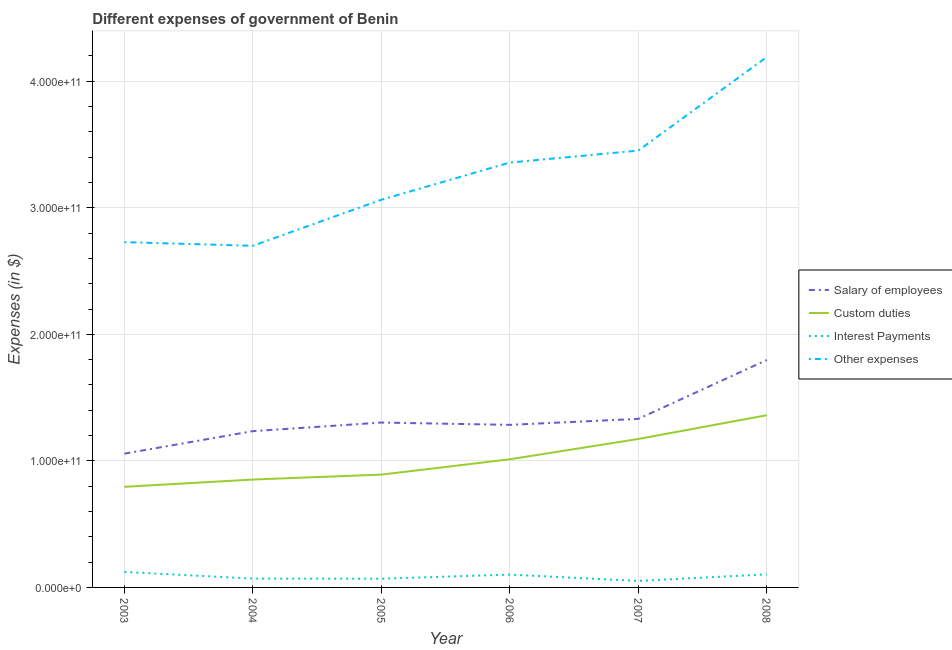How many different coloured lines are there?
Provide a succinct answer. 4. Does the line corresponding to amount spent on custom duties intersect with the line corresponding to amount spent on salary of employees?
Provide a succinct answer. No. Is the number of lines equal to the number of legend labels?
Your answer should be compact. Yes. What is the amount spent on custom duties in 2003?
Make the answer very short. 7.95e+1. Across all years, what is the maximum amount spent on other expenses?
Keep it short and to the point. 4.19e+11. Across all years, what is the minimum amount spent on interest payments?
Provide a succinct answer. 5.13e+09. In which year was the amount spent on custom duties maximum?
Ensure brevity in your answer.  2008. What is the total amount spent on custom duties in the graph?
Your response must be concise. 6.09e+11. What is the difference between the amount spent on interest payments in 2003 and that in 2007?
Ensure brevity in your answer.  7.14e+09. What is the difference between the amount spent on salary of employees in 2005 and the amount spent on custom duties in 2008?
Your answer should be compact. -5.80e+09. What is the average amount spent on salary of employees per year?
Offer a very short reply. 1.33e+11. In the year 2008, what is the difference between the amount spent on salary of employees and amount spent on custom duties?
Make the answer very short. 4.36e+1. In how many years, is the amount spent on interest payments greater than 140000000000 $?
Provide a succinct answer. 0. What is the ratio of the amount spent on other expenses in 2007 to that in 2008?
Keep it short and to the point. 0.82. What is the difference between the highest and the second highest amount spent on other expenses?
Your answer should be compact. 7.39e+1. What is the difference between the highest and the lowest amount spent on custom duties?
Make the answer very short. 5.66e+1. In how many years, is the amount spent on custom duties greater than the average amount spent on custom duties taken over all years?
Offer a very short reply. 2. Is it the case that in every year, the sum of the amount spent on interest payments and amount spent on other expenses is greater than the sum of amount spent on custom duties and amount spent on salary of employees?
Provide a succinct answer. Yes. Is the amount spent on custom duties strictly greater than the amount spent on other expenses over the years?
Make the answer very short. No. Is the amount spent on interest payments strictly less than the amount spent on salary of employees over the years?
Give a very brief answer. Yes. What is the difference between two consecutive major ticks on the Y-axis?
Your answer should be very brief. 1.00e+11. Are the values on the major ticks of Y-axis written in scientific E-notation?
Give a very brief answer. Yes. Does the graph contain any zero values?
Give a very brief answer. No. Does the graph contain grids?
Your response must be concise. Yes. How are the legend labels stacked?
Provide a short and direct response. Vertical. What is the title of the graph?
Offer a terse response. Different expenses of government of Benin. Does "Luxembourg" appear as one of the legend labels in the graph?
Keep it short and to the point. No. What is the label or title of the Y-axis?
Give a very brief answer. Expenses (in $). What is the Expenses (in $) of Salary of employees in 2003?
Keep it short and to the point. 1.06e+11. What is the Expenses (in $) of Custom duties in 2003?
Give a very brief answer. 7.95e+1. What is the Expenses (in $) in Interest Payments in 2003?
Offer a very short reply. 1.23e+1. What is the Expenses (in $) of Other expenses in 2003?
Ensure brevity in your answer.  2.73e+11. What is the Expenses (in $) of Salary of employees in 2004?
Your response must be concise. 1.23e+11. What is the Expenses (in $) in Custom duties in 2004?
Provide a short and direct response. 8.52e+1. What is the Expenses (in $) in Interest Payments in 2004?
Give a very brief answer. 6.97e+09. What is the Expenses (in $) of Other expenses in 2004?
Offer a very short reply. 2.70e+11. What is the Expenses (in $) in Salary of employees in 2005?
Ensure brevity in your answer.  1.30e+11. What is the Expenses (in $) in Custom duties in 2005?
Keep it short and to the point. 8.91e+1. What is the Expenses (in $) in Interest Payments in 2005?
Make the answer very short. 6.89e+09. What is the Expenses (in $) in Other expenses in 2005?
Provide a succinct answer. 3.06e+11. What is the Expenses (in $) in Salary of employees in 2006?
Keep it short and to the point. 1.28e+11. What is the Expenses (in $) of Custom duties in 2006?
Offer a very short reply. 1.01e+11. What is the Expenses (in $) of Interest Payments in 2006?
Your answer should be very brief. 1.01e+1. What is the Expenses (in $) of Other expenses in 2006?
Ensure brevity in your answer.  3.36e+11. What is the Expenses (in $) of Salary of employees in 2007?
Make the answer very short. 1.33e+11. What is the Expenses (in $) in Custom duties in 2007?
Your answer should be compact. 1.17e+11. What is the Expenses (in $) of Interest Payments in 2007?
Make the answer very short. 5.13e+09. What is the Expenses (in $) in Other expenses in 2007?
Provide a succinct answer. 3.45e+11. What is the Expenses (in $) in Salary of employees in 2008?
Ensure brevity in your answer.  1.80e+11. What is the Expenses (in $) in Custom duties in 2008?
Offer a terse response. 1.36e+11. What is the Expenses (in $) of Interest Payments in 2008?
Your answer should be compact. 1.03e+1. What is the Expenses (in $) in Other expenses in 2008?
Ensure brevity in your answer.  4.19e+11. Across all years, what is the maximum Expenses (in $) of Salary of employees?
Give a very brief answer. 1.80e+11. Across all years, what is the maximum Expenses (in $) of Custom duties?
Your answer should be very brief. 1.36e+11. Across all years, what is the maximum Expenses (in $) of Interest Payments?
Make the answer very short. 1.23e+1. Across all years, what is the maximum Expenses (in $) in Other expenses?
Offer a terse response. 4.19e+11. Across all years, what is the minimum Expenses (in $) in Salary of employees?
Ensure brevity in your answer.  1.06e+11. Across all years, what is the minimum Expenses (in $) in Custom duties?
Provide a short and direct response. 7.95e+1. Across all years, what is the minimum Expenses (in $) of Interest Payments?
Give a very brief answer. 5.13e+09. Across all years, what is the minimum Expenses (in $) of Other expenses?
Your answer should be compact. 2.70e+11. What is the total Expenses (in $) in Salary of employees in the graph?
Your response must be concise. 8.01e+11. What is the total Expenses (in $) of Custom duties in the graph?
Your answer should be compact. 6.09e+11. What is the total Expenses (in $) of Interest Payments in the graph?
Keep it short and to the point. 5.17e+1. What is the total Expenses (in $) in Other expenses in the graph?
Your answer should be compact. 1.95e+12. What is the difference between the Expenses (in $) in Salary of employees in 2003 and that in 2004?
Keep it short and to the point. -1.78e+1. What is the difference between the Expenses (in $) of Custom duties in 2003 and that in 2004?
Provide a succinct answer. -5.75e+09. What is the difference between the Expenses (in $) in Interest Payments in 2003 and that in 2004?
Your response must be concise. 5.30e+09. What is the difference between the Expenses (in $) in Other expenses in 2003 and that in 2004?
Your answer should be compact. 2.89e+09. What is the difference between the Expenses (in $) in Salary of employees in 2003 and that in 2005?
Keep it short and to the point. -2.46e+1. What is the difference between the Expenses (in $) of Custom duties in 2003 and that in 2005?
Your response must be concise. -9.65e+09. What is the difference between the Expenses (in $) of Interest Payments in 2003 and that in 2005?
Provide a succinct answer. 5.38e+09. What is the difference between the Expenses (in $) of Other expenses in 2003 and that in 2005?
Your answer should be compact. -3.35e+1. What is the difference between the Expenses (in $) in Salary of employees in 2003 and that in 2006?
Your answer should be compact. -2.27e+1. What is the difference between the Expenses (in $) in Custom duties in 2003 and that in 2006?
Keep it short and to the point. -2.18e+1. What is the difference between the Expenses (in $) of Interest Payments in 2003 and that in 2006?
Keep it short and to the point. 2.12e+09. What is the difference between the Expenses (in $) in Other expenses in 2003 and that in 2006?
Offer a very short reply. -6.29e+1. What is the difference between the Expenses (in $) in Salary of employees in 2003 and that in 2007?
Your answer should be compact. -2.75e+1. What is the difference between the Expenses (in $) in Custom duties in 2003 and that in 2007?
Make the answer very short. -3.78e+1. What is the difference between the Expenses (in $) in Interest Payments in 2003 and that in 2007?
Keep it short and to the point. 7.14e+09. What is the difference between the Expenses (in $) of Other expenses in 2003 and that in 2007?
Provide a short and direct response. -7.23e+1. What is the difference between the Expenses (in $) in Salary of employees in 2003 and that in 2008?
Offer a terse response. -7.40e+1. What is the difference between the Expenses (in $) in Custom duties in 2003 and that in 2008?
Offer a terse response. -5.66e+1. What is the difference between the Expenses (in $) of Interest Payments in 2003 and that in 2008?
Your answer should be very brief. 1.92e+09. What is the difference between the Expenses (in $) in Other expenses in 2003 and that in 2008?
Give a very brief answer. -1.46e+11. What is the difference between the Expenses (in $) in Salary of employees in 2004 and that in 2005?
Offer a very short reply. -6.80e+09. What is the difference between the Expenses (in $) of Custom duties in 2004 and that in 2005?
Your answer should be very brief. -3.90e+09. What is the difference between the Expenses (in $) of Interest Payments in 2004 and that in 2005?
Make the answer very short. 8.00e+07. What is the difference between the Expenses (in $) in Other expenses in 2004 and that in 2005?
Your response must be concise. -3.64e+1. What is the difference between the Expenses (in $) of Salary of employees in 2004 and that in 2006?
Your answer should be very brief. -4.99e+09. What is the difference between the Expenses (in $) of Custom duties in 2004 and that in 2006?
Ensure brevity in your answer.  -1.60e+1. What is the difference between the Expenses (in $) of Interest Payments in 2004 and that in 2006?
Provide a short and direct response. -3.18e+09. What is the difference between the Expenses (in $) of Other expenses in 2004 and that in 2006?
Give a very brief answer. -6.58e+1. What is the difference between the Expenses (in $) in Salary of employees in 2004 and that in 2007?
Offer a terse response. -9.71e+09. What is the difference between the Expenses (in $) in Custom duties in 2004 and that in 2007?
Give a very brief answer. -3.21e+1. What is the difference between the Expenses (in $) in Interest Payments in 2004 and that in 2007?
Offer a terse response. 1.84e+09. What is the difference between the Expenses (in $) in Other expenses in 2004 and that in 2007?
Your answer should be very brief. -7.52e+1. What is the difference between the Expenses (in $) in Salary of employees in 2004 and that in 2008?
Offer a terse response. -5.62e+1. What is the difference between the Expenses (in $) of Custom duties in 2004 and that in 2008?
Your response must be concise. -5.08e+1. What is the difference between the Expenses (in $) in Interest Payments in 2004 and that in 2008?
Your answer should be compact. -3.38e+09. What is the difference between the Expenses (in $) in Other expenses in 2004 and that in 2008?
Provide a short and direct response. -1.49e+11. What is the difference between the Expenses (in $) of Salary of employees in 2005 and that in 2006?
Provide a succinct answer. 1.81e+09. What is the difference between the Expenses (in $) in Custom duties in 2005 and that in 2006?
Your answer should be compact. -1.21e+1. What is the difference between the Expenses (in $) in Interest Payments in 2005 and that in 2006?
Make the answer very short. -3.26e+09. What is the difference between the Expenses (in $) in Other expenses in 2005 and that in 2006?
Ensure brevity in your answer.  -2.94e+1. What is the difference between the Expenses (in $) of Salary of employees in 2005 and that in 2007?
Give a very brief answer. -2.91e+09. What is the difference between the Expenses (in $) in Custom duties in 2005 and that in 2007?
Offer a very short reply. -2.82e+1. What is the difference between the Expenses (in $) of Interest Payments in 2005 and that in 2007?
Your answer should be very brief. 1.76e+09. What is the difference between the Expenses (in $) of Other expenses in 2005 and that in 2007?
Make the answer very short. -3.88e+1. What is the difference between the Expenses (in $) of Salary of employees in 2005 and that in 2008?
Your answer should be compact. -4.94e+1. What is the difference between the Expenses (in $) in Custom duties in 2005 and that in 2008?
Provide a short and direct response. -4.69e+1. What is the difference between the Expenses (in $) in Interest Payments in 2005 and that in 2008?
Give a very brief answer. -3.46e+09. What is the difference between the Expenses (in $) in Other expenses in 2005 and that in 2008?
Offer a terse response. -1.13e+11. What is the difference between the Expenses (in $) in Salary of employees in 2006 and that in 2007?
Your response must be concise. -4.72e+09. What is the difference between the Expenses (in $) of Custom duties in 2006 and that in 2007?
Offer a very short reply. -1.60e+1. What is the difference between the Expenses (in $) in Interest Payments in 2006 and that in 2007?
Keep it short and to the point. 5.02e+09. What is the difference between the Expenses (in $) in Other expenses in 2006 and that in 2007?
Provide a short and direct response. -9.44e+09. What is the difference between the Expenses (in $) of Salary of employees in 2006 and that in 2008?
Offer a terse response. -5.12e+1. What is the difference between the Expenses (in $) of Custom duties in 2006 and that in 2008?
Your response must be concise. -3.48e+1. What is the difference between the Expenses (in $) of Interest Payments in 2006 and that in 2008?
Provide a succinct answer. -2.00e+08. What is the difference between the Expenses (in $) in Other expenses in 2006 and that in 2008?
Offer a very short reply. -8.34e+1. What is the difference between the Expenses (in $) in Salary of employees in 2007 and that in 2008?
Provide a short and direct response. -4.65e+1. What is the difference between the Expenses (in $) of Custom duties in 2007 and that in 2008?
Keep it short and to the point. -1.88e+1. What is the difference between the Expenses (in $) in Interest Payments in 2007 and that in 2008?
Your answer should be very brief. -5.22e+09. What is the difference between the Expenses (in $) in Other expenses in 2007 and that in 2008?
Your answer should be compact. -7.39e+1. What is the difference between the Expenses (in $) of Salary of employees in 2003 and the Expenses (in $) of Custom duties in 2004?
Make the answer very short. 2.05e+1. What is the difference between the Expenses (in $) of Salary of employees in 2003 and the Expenses (in $) of Interest Payments in 2004?
Your response must be concise. 9.88e+1. What is the difference between the Expenses (in $) of Salary of employees in 2003 and the Expenses (in $) of Other expenses in 2004?
Your answer should be very brief. -1.64e+11. What is the difference between the Expenses (in $) in Custom duties in 2003 and the Expenses (in $) in Interest Payments in 2004?
Provide a short and direct response. 7.25e+1. What is the difference between the Expenses (in $) in Custom duties in 2003 and the Expenses (in $) in Other expenses in 2004?
Your answer should be very brief. -1.90e+11. What is the difference between the Expenses (in $) in Interest Payments in 2003 and the Expenses (in $) in Other expenses in 2004?
Your answer should be compact. -2.58e+11. What is the difference between the Expenses (in $) of Salary of employees in 2003 and the Expenses (in $) of Custom duties in 2005?
Provide a succinct answer. 1.66e+1. What is the difference between the Expenses (in $) of Salary of employees in 2003 and the Expenses (in $) of Interest Payments in 2005?
Provide a short and direct response. 9.88e+1. What is the difference between the Expenses (in $) of Salary of employees in 2003 and the Expenses (in $) of Other expenses in 2005?
Ensure brevity in your answer.  -2.01e+11. What is the difference between the Expenses (in $) in Custom duties in 2003 and the Expenses (in $) in Interest Payments in 2005?
Keep it short and to the point. 7.26e+1. What is the difference between the Expenses (in $) of Custom duties in 2003 and the Expenses (in $) of Other expenses in 2005?
Give a very brief answer. -2.27e+11. What is the difference between the Expenses (in $) of Interest Payments in 2003 and the Expenses (in $) of Other expenses in 2005?
Ensure brevity in your answer.  -2.94e+11. What is the difference between the Expenses (in $) of Salary of employees in 2003 and the Expenses (in $) of Custom duties in 2006?
Your answer should be very brief. 4.46e+09. What is the difference between the Expenses (in $) in Salary of employees in 2003 and the Expenses (in $) in Interest Payments in 2006?
Offer a terse response. 9.56e+1. What is the difference between the Expenses (in $) in Salary of employees in 2003 and the Expenses (in $) in Other expenses in 2006?
Keep it short and to the point. -2.30e+11. What is the difference between the Expenses (in $) in Custom duties in 2003 and the Expenses (in $) in Interest Payments in 2006?
Give a very brief answer. 6.93e+1. What is the difference between the Expenses (in $) in Custom duties in 2003 and the Expenses (in $) in Other expenses in 2006?
Your answer should be very brief. -2.56e+11. What is the difference between the Expenses (in $) of Interest Payments in 2003 and the Expenses (in $) of Other expenses in 2006?
Keep it short and to the point. -3.23e+11. What is the difference between the Expenses (in $) in Salary of employees in 2003 and the Expenses (in $) in Custom duties in 2007?
Provide a succinct answer. -1.16e+1. What is the difference between the Expenses (in $) of Salary of employees in 2003 and the Expenses (in $) of Interest Payments in 2007?
Your answer should be very brief. 1.01e+11. What is the difference between the Expenses (in $) of Salary of employees in 2003 and the Expenses (in $) of Other expenses in 2007?
Your answer should be compact. -2.39e+11. What is the difference between the Expenses (in $) in Custom duties in 2003 and the Expenses (in $) in Interest Payments in 2007?
Provide a short and direct response. 7.44e+1. What is the difference between the Expenses (in $) in Custom duties in 2003 and the Expenses (in $) in Other expenses in 2007?
Offer a very short reply. -2.66e+11. What is the difference between the Expenses (in $) of Interest Payments in 2003 and the Expenses (in $) of Other expenses in 2007?
Ensure brevity in your answer.  -3.33e+11. What is the difference between the Expenses (in $) in Salary of employees in 2003 and the Expenses (in $) in Custom duties in 2008?
Keep it short and to the point. -3.04e+1. What is the difference between the Expenses (in $) in Salary of employees in 2003 and the Expenses (in $) in Interest Payments in 2008?
Your response must be concise. 9.54e+1. What is the difference between the Expenses (in $) in Salary of employees in 2003 and the Expenses (in $) in Other expenses in 2008?
Keep it short and to the point. -3.13e+11. What is the difference between the Expenses (in $) of Custom duties in 2003 and the Expenses (in $) of Interest Payments in 2008?
Your response must be concise. 6.91e+1. What is the difference between the Expenses (in $) in Custom duties in 2003 and the Expenses (in $) in Other expenses in 2008?
Your answer should be very brief. -3.40e+11. What is the difference between the Expenses (in $) in Interest Payments in 2003 and the Expenses (in $) in Other expenses in 2008?
Give a very brief answer. -4.07e+11. What is the difference between the Expenses (in $) in Salary of employees in 2004 and the Expenses (in $) in Custom duties in 2005?
Ensure brevity in your answer.  3.43e+1. What is the difference between the Expenses (in $) in Salary of employees in 2004 and the Expenses (in $) in Interest Payments in 2005?
Offer a terse response. 1.17e+11. What is the difference between the Expenses (in $) in Salary of employees in 2004 and the Expenses (in $) in Other expenses in 2005?
Ensure brevity in your answer.  -1.83e+11. What is the difference between the Expenses (in $) in Custom duties in 2004 and the Expenses (in $) in Interest Payments in 2005?
Your answer should be compact. 7.84e+1. What is the difference between the Expenses (in $) of Custom duties in 2004 and the Expenses (in $) of Other expenses in 2005?
Give a very brief answer. -2.21e+11. What is the difference between the Expenses (in $) of Interest Payments in 2004 and the Expenses (in $) of Other expenses in 2005?
Your answer should be compact. -2.99e+11. What is the difference between the Expenses (in $) of Salary of employees in 2004 and the Expenses (in $) of Custom duties in 2006?
Make the answer very short. 2.22e+1. What is the difference between the Expenses (in $) of Salary of employees in 2004 and the Expenses (in $) of Interest Payments in 2006?
Ensure brevity in your answer.  1.13e+11. What is the difference between the Expenses (in $) of Salary of employees in 2004 and the Expenses (in $) of Other expenses in 2006?
Your answer should be very brief. -2.12e+11. What is the difference between the Expenses (in $) in Custom duties in 2004 and the Expenses (in $) in Interest Payments in 2006?
Your response must be concise. 7.51e+1. What is the difference between the Expenses (in $) in Custom duties in 2004 and the Expenses (in $) in Other expenses in 2006?
Keep it short and to the point. -2.50e+11. What is the difference between the Expenses (in $) of Interest Payments in 2004 and the Expenses (in $) of Other expenses in 2006?
Offer a very short reply. -3.29e+11. What is the difference between the Expenses (in $) in Salary of employees in 2004 and the Expenses (in $) in Custom duties in 2007?
Your answer should be compact. 6.18e+09. What is the difference between the Expenses (in $) of Salary of employees in 2004 and the Expenses (in $) of Interest Payments in 2007?
Your answer should be compact. 1.18e+11. What is the difference between the Expenses (in $) in Salary of employees in 2004 and the Expenses (in $) in Other expenses in 2007?
Your answer should be compact. -2.22e+11. What is the difference between the Expenses (in $) of Custom duties in 2004 and the Expenses (in $) of Interest Payments in 2007?
Make the answer very short. 8.01e+1. What is the difference between the Expenses (in $) in Custom duties in 2004 and the Expenses (in $) in Other expenses in 2007?
Provide a succinct answer. -2.60e+11. What is the difference between the Expenses (in $) in Interest Payments in 2004 and the Expenses (in $) in Other expenses in 2007?
Offer a terse response. -3.38e+11. What is the difference between the Expenses (in $) of Salary of employees in 2004 and the Expenses (in $) of Custom duties in 2008?
Keep it short and to the point. -1.26e+1. What is the difference between the Expenses (in $) in Salary of employees in 2004 and the Expenses (in $) in Interest Payments in 2008?
Provide a succinct answer. 1.13e+11. What is the difference between the Expenses (in $) in Salary of employees in 2004 and the Expenses (in $) in Other expenses in 2008?
Make the answer very short. -2.96e+11. What is the difference between the Expenses (in $) of Custom duties in 2004 and the Expenses (in $) of Interest Payments in 2008?
Provide a succinct answer. 7.49e+1. What is the difference between the Expenses (in $) in Custom duties in 2004 and the Expenses (in $) in Other expenses in 2008?
Your response must be concise. -3.34e+11. What is the difference between the Expenses (in $) in Interest Payments in 2004 and the Expenses (in $) in Other expenses in 2008?
Provide a short and direct response. -4.12e+11. What is the difference between the Expenses (in $) of Salary of employees in 2005 and the Expenses (in $) of Custom duties in 2006?
Keep it short and to the point. 2.90e+1. What is the difference between the Expenses (in $) of Salary of employees in 2005 and the Expenses (in $) of Interest Payments in 2006?
Make the answer very short. 1.20e+11. What is the difference between the Expenses (in $) of Salary of employees in 2005 and the Expenses (in $) of Other expenses in 2006?
Your response must be concise. -2.05e+11. What is the difference between the Expenses (in $) in Custom duties in 2005 and the Expenses (in $) in Interest Payments in 2006?
Give a very brief answer. 7.90e+1. What is the difference between the Expenses (in $) in Custom duties in 2005 and the Expenses (in $) in Other expenses in 2006?
Offer a very short reply. -2.47e+11. What is the difference between the Expenses (in $) of Interest Payments in 2005 and the Expenses (in $) of Other expenses in 2006?
Your response must be concise. -3.29e+11. What is the difference between the Expenses (in $) in Salary of employees in 2005 and the Expenses (in $) in Custom duties in 2007?
Your answer should be very brief. 1.30e+1. What is the difference between the Expenses (in $) of Salary of employees in 2005 and the Expenses (in $) of Interest Payments in 2007?
Keep it short and to the point. 1.25e+11. What is the difference between the Expenses (in $) in Salary of employees in 2005 and the Expenses (in $) in Other expenses in 2007?
Provide a succinct answer. -2.15e+11. What is the difference between the Expenses (in $) of Custom duties in 2005 and the Expenses (in $) of Interest Payments in 2007?
Your answer should be very brief. 8.40e+1. What is the difference between the Expenses (in $) in Custom duties in 2005 and the Expenses (in $) in Other expenses in 2007?
Your response must be concise. -2.56e+11. What is the difference between the Expenses (in $) in Interest Payments in 2005 and the Expenses (in $) in Other expenses in 2007?
Make the answer very short. -3.38e+11. What is the difference between the Expenses (in $) in Salary of employees in 2005 and the Expenses (in $) in Custom duties in 2008?
Provide a short and direct response. -5.80e+09. What is the difference between the Expenses (in $) in Salary of employees in 2005 and the Expenses (in $) in Interest Payments in 2008?
Keep it short and to the point. 1.20e+11. What is the difference between the Expenses (in $) of Salary of employees in 2005 and the Expenses (in $) of Other expenses in 2008?
Your answer should be very brief. -2.89e+11. What is the difference between the Expenses (in $) of Custom duties in 2005 and the Expenses (in $) of Interest Payments in 2008?
Provide a succinct answer. 7.88e+1. What is the difference between the Expenses (in $) in Custom duties in 2005 and the Expenses (in $) in Other expenses in 2008?
Make the answer very short. -3.30e+11. What is the difference between the Expenses (in $) of Interest Payments in 2005 and the Expenses (in $) of Other expenses in 2008?
Offer a very short reply. -4.12e+11. What is the difference between the Expenses (in $) of Salary of employees in 2006 and the Expenses (in $) of Custom duties in 2007?
Provide a succinct answer. 1.12e+1. What is the difference between the Expenses (in $) of Salary of employees in 2006 and the Expenses (in $) of Interest Payments in 2007?
Keep it short and to the point. 1.23e+11. What is the difference between the Expenses (in $) of Salary of employees in 2006 and the Expenses (in $) of Other expenses in 2007?
Give a very brief answer. -2.17e+11. What is the difference between the Expenses (in $) in Custom duties in 2006 and the Expenses (in $) in Interest Payments in 2007?
Provide a succinct answer. 9.61e+1. What is the difference between the Expenses (in $) in Custom duties in 2006 and the Expenses (in $) in Other expenses in 2007?
Your response must be concise. -2.44e+11. What is the difference between the Expenses (in $) in Interest Payments in 2006 and the Expenses (in $) in Other expenses in 2007?
Provide a short and direct response. -3.35e+11. What is the difference between the Expenses (in $) in Salary of employees in 2006 and the Expenses (in $) in Custom duties in 2008?
Keep it short and to the point. -7.61e+09. What is the difference between the Expenses (in $) in Salary of employees in 2006 and the Expenses (in $) in Interest Payments in 2008?
Offer a very short reply. 1.18e+11. What is the difference between the Expenses (in $) of Salary of employees in 2006 and the Expenses (in $) of Other expenses in 2008?
Provide a short and direct response. -2.91e+11. What is the difference between the Expenses (in $) of Custom duties in 2006 and the Expenses (in $) of Interest Payments in 2008?
Ensure brevity in your answer.  9.09e+1. What is the difference between the Expenses (in $) in Custom duties in 2006 and the Expenses (in $) in Other expenses in 2008?
Ensure brevity in your answer.  -3.18e+11. What is the difference between the Expenses (in $) in Interest Payments in 2006 and the Expenses (in $) in Other expenses in 2008?
Provide a succinct answer. -4.09e+11. What is the difference between the Expenses (in $) in Salary of employees in 2007 and the Expenses (in $) in Custom duties in 2008?
Your answer should be compact. -2.89e+09. What is the difference between the Expenses (in $) of Salary of employees in 2007 and the Expenses (in $) of Interest Payments in 2008?
Provide a short and direct response. 1.23e+11. What is the difference between the Expenses (in $) in Salary of employees in 2007 and the Expenses (in $) in Other expenses in 2008?
Give a very brief answer. -2.86e+11. What is the difference between the Expenses (in $) in Custom duties in 2007 and the Expenses (in $) in Interest Payments in 2008?
Make the answer very short. 1.07e+11. What is the difference between the Expenses (in $) in Custom duties in 2007 and the Expenses (in $) in Other expenses in 2008?
Your answer should be very brief. -3.02e+11. What is the difference between the Expenses (in $) in Interest Payments in 2007 and the Expenses (in $) in Other expenses in 2008?
Provide a succinct answer. -4.14e+11. What is the average Expenses (in $) in Salary of employees per year?
Offer a very short reply. 1.33e+11. What is the average Expenses (in $) of Custom duties per year?
Your answer should be very brief. 1.01e+11. What is the average Expenses (in $) in Interest Payments per year?
Your answer should be compact. 8.62e+09. What is the average Expenses (in $) in Other expenses per year?
Keep it short and to the point. 3.25e+11. In the year 2003, what is the difference between the Expenses (in $) in Salary of employees and Expenses (in $) in Custom duties?
Offer a terse response. 2.62e+1. In the year 2003, what is the difference between the Expenses (in $) in Salary of employees and Expenses (in $) in Interest Payments?
Keep it short and to the point. 9.35e+1. In the year 2003, what is the difference between the Expenses (in $) in Salary of employees and Expenses (in $) in Other expenses?
Ensure brevity in your answer.  -1.67e+11. In the year 2003, what is the difference between the Expenses (in $) in Custom duties and Expenses (in $) in Interest Payments?
Offer a very short reply. 6.72e+1. In the year 2003, what is the difference between the Expenses (in $) of Custom duties and Expenses (in $) of Other expenses?
Ensure brevity in your answer.  -1.93e+11. In the year 2003, what is the difference between the Expenses (in $) of Interest Payments and Expenses (in $) of Other expenses?
Offer a terse response. -2.61e+11. In the year 2004, what is the difference between the Expenses (in $) in Salary of employees and Expenses (in $) in Custom duties?
Make the answer very short. 3.82e+1. In the year 2004, what is the difference between the Expenses (in $) in Salary of employees and Expenses (in $) in Interest Payments?
Make the answer very short. 1.17e+11. In the year 2004, what is the difference between the Expenses (in $) of Salary of employees and Expenses (in $) of Other expenses?
Offer a terse response. -1.46e+11. In the year 2004, what is the difference between the Expenses (in $) of Custom duties and Expenses (in $) of Interest Payments?
Keep it short and to the point. 7.83e+1. In the year 2004, what is the difference between the Expenses (in $) in Custom duties and Expenses (in $) in Other expenses?
Make the answer very short. -1.85e+11. In the year 2004, what is the difference between the Expenses (in $) in Interest Payments and Expenses (in $) in Other expenses?
Offer a very short reply. -2.63e+11. In the year 2005, what is the difference between the Expenses (in $) in Salary of employees and Expenses (in $) in Custom duties?
Offer a very short reply. 4.11e+1. In the year 2005, what is the difference between the Expenses (in $) in Salary of employees and Expenses (in $) in Interest Payments?
Provide a succinct answer. 1.23e+11. In the year 2005, what is the difference between the Expenses (in $) of Salary of employees and Expenses (in $) of Other expenses?
Ensure brevity in your answer.  -1.76e+11. In the year 2005, what is the difference between the Expenses (in $) in Custom duties and Expenses (in $) in Interest Payments?
Keep it short and to the point. 8.23e+1. In the year 2005, what is the difference between the Expenses (in $) of Custom duties and Expenses (in $) of Other expenses?
Your response must be concise. -2.17e+11. In the year 2005, what is the difference between the Expenses (in $) of Interest Payments and Expenses (in $) of Other expenses?
Provide a succinct answer. -2.99e+11. In the year 2006, what is the difference between the Expenses (in $) in Salary of employees and Expenses (in $) in Custom duties?
Your answer should be compact. 2.72e+1. In the year 2006, what is the difference between the Expenses (in $) of Salary of employees and Expenses (in $) of Interest Payments?
Keep it short and to the point. 1.18e+11. In the year 2006, what is the difference between the Expenses (in $) in Salary of employees and Expenses (in $) in Other expenses?
Offer a terse response. -2.07e+11. In the year 2006, what is the difference between the Expenses (in $) in Custom duties and Expenses (in $) in Interest Payments?
Your response must be concise. 9.11e+1. In the year 2006, what is the difference between the Expenses (in $) in Custom duties and Expenses (in $) in Other expenses?
Your response must be concise. -2.34e+11. In the year 2006, what is the difference between the Expenses (in $) in Interest Payments and Expenses (in $) in Other expenses?
Your answer should be very brief. -3.26e+11. In the year 2007, what is the difference between the Expenses (in $) in Salary of employees and Expenses (in $) in Custom duties?
Provide a short and direct response. 1.59e+1. In the year 2007, what is the difference between the Expenses (in $) in Salary of employees and Expenses (in $) in Interest Payments?
Your answer should be very brief. 1.28e+11. In the year 2007, what is the difference between the Expenses (in $) in Salary of employees and Expenses (in $) in Other expenses?
Make the answer very short. -2.12e+11. In the year 2007, what is the difference between the Expenses (in $) of Custom duties and Expenses (in $) of Interest Payments?
Provide a succinct answer. 1.12e+11. In the year 2007, what is the difference between the Expenses (in $) of Custom duties and Expenses (in $) of Other expenses?
Offer a terse response. -2.28e+11. In the year 2007, what is the difference between the Expenses (in $) of Interest Payments and Expenses (in $) of Other expenses?
Your response must be concise. -3.40e+11. In the year 2008, what is the difference between the Expenses (in $) of Salary of employees and Expenses (in $) of Custom duties?
Make the answer very short. 4.36e+1. In the year 2008, what is the difference between the Expenses (in $) in Salary of employees and Expenses (in $) in Interest Payments?
Provide a short and direct response. 1.69e+11. In the year 2008, what is the difference between the Expenses (in $) of Salary of employees and Expenses (in $) of Other expenses?
Offer a terse response. -2.39e+11. In the year 2008, what is the difference between the Expenses (in $) in Custom duties and Expenses (in $) in Interest Payments?
Ensure brevity in your answer.  1.26e+11. In the year 2008, what is the difference between the Expenses (in $) of Custom duties and Expenses (in $) of Other expenses?
Offer a terse response. -2.83e+11. In the year 2008, what is the difference between the Expenses (in $) of Interest Payments and Expenses (in $) of Other expenses?
Provide a short and direct response. -4.09e+11. What is the ratio of the Expenses (in $) in Salary of employees in 2003 to that in 2004?
Keep it short and to the point. 0.86. What is the ratio of the Expenses (in $) of Custom duties in 2003 to that in 2004?
Your response must be concise. 0.93. What is the ratio of the Expenses (in $) in Interest Payments in 2003 to that in 2004?
Offer a terse response. 1.76. What is the ratio of the Expenses (in $) of Other expenses in 2003 to that in 2004?
Offer a very short reply. 1.01. What is the ratio of the Expenses (in $) in Salary of employees in 2003 to that in 2005?
Provide a succinct answer. 0.81. What is the ratio of the Expenses (in $) of Custom duties in 2003 to that in 2005?
Ensure brevity in your answer.  0.89. What is the ratio of the Expenses (in $) in Interest Payments in 2003 to that in 2005?
Provide a succinct answer. 1.78. What is the ratio of the Expenses (in $) of Other expenses in 2003 to that in 2005?
Give a very brief answer. 0.89. What is the ratio of the Expenses (in $) in Salary of employees in 2003 to that in 2006?
Your answer should be very brief. 0.82. What is the ratio of the Expenses (in $) of Custom duties in 2003 to that in 2006?
Ensure brevity in your answer.  0.79. What is the ratio of the Expenses (in $) in Interest Payments in 2003 to that in 2006?
Your answer should be compact. 1.21. What is the ratio of the Expenses (in $) of Other expenses in 2003 to that in 2006?
Keep it short and to the point. 0.81. What is the ratio of the Expenses (in $) of Salary of employees in 2003 to that in 2007?
Give a very brief answer. 0.79. What is the ratio of the Expenses (in $) in Custom duties in 2003 to that in 2007?
Offer a very short reply. 0.68. What is the ratio of the Expenses (in $) of Interest Payments in 2003 to that in 2007?
Your response must be concise. 2.39. What is the ratio of the Expenses (in $) in Other expenses in 2003 to that in 2007?
Offer a terse response. 0.79. What is the ratio of the Expenses (in $) in Salary of employees in 2003 to that in 2008?
Your answer should be compact. 0.59. What is the ratio of the Expenses (in $) of Custom duties in 2003 to that in 2008?
Offer a very short reply. 0.58. What is the ratio of the Expenses (in $) in Interest Payments in 2003 to that in 2008?
Your response must be concise. 1.19. What is the ratio of the Expenses (in $) in Other expenses in 2003 to that in 2008?
Provide a succinct answer. 0.65. What is the ratio of the Expenses (in $) of Salary of employees in 2004 to that in 2005?
Ensure brevity in your answer.  0.95. What is the ratio of the Expenses (in $) of Custom duties in 2004 to that in 2005?
Provide a short and direct response. 0.96. What is the ratio of the Expenses (in $) of Interest Payments in 2004 to that in 2005?
Provide a short and direct response. 1.01. What is the ratio of the Expenses (in $) in Other expenses in 2004 to that in 2005?
Your answer should be compact. 0.88. What is the ratio of the Expenses (in $) of Salary of employees in 2004 to that in 2006?
Make the answer very short. 0.96. What is the ratio of the Expenses (in $) in Custom duties in 2004 to that in 2006?
Provide a short and direct response. 0.84. What is the ratio of the Expenses (in $) of Interest Payments in 2004 to that in 2006?
Offer a very short reply. 0.69. What is the ratio of the Expenses (in $) of Other expenses in 2004 to that in 2006?
Your answer should be very brief. 0.8. What is the ratio of the Expenses (in $) in Salary of employees in 2004 to that in 2007?
Ensure brevity in your answer.  0.93. What is the ratio of the Expenses (in $) of Custom duties in 2004 to that in 2007?
Your answer should be very brief. 0.73. What is the ratio of the Expenses (in $) in Interest Payments in 2004 to that in 2007?
Give a very brief answer. 1.36. What is the ratio of the Expenses (in $) in Other expenses in 2004 to that in 2007?
Give a very brief answer. 0.78. What is the ratio of the Expenses (in $) of Salary of employees in 2004 to that in 2008?
Give a very brief answer. 0.69. What is the ratio of the Expenses (in $) of Custom duties in 2004 to that in 2008?
Keep it short and to the point. 0.63. What is the ratio of the Expenses (in $) of Interest Payments in 2004 to that in 2008?
Your response must be concise. 0.67. What is the ratio of the Expenses (in $) of Other expenses in 2004 to that in 2008?
Provide a succinct answer. 0.64. What is the ratio of the Expenses (in $) of Salary of employees in 2005 to that in 2006?
Ensure brevity in your answer.  1.01. What is the ratio of the Expenses (in $) in Custom duties in 2005 to that in 2006?
Offer a very short reply. 0.88. What is the ratio of the Expenses (in $) in Interest Payments in 2005 to that in 2006?
Your response must be concise. 0.68. What is the ratio of the Expenses (in $) of Other expenses in 2005 to that in 2006?
Offer a very short reply. 0.91. What is the ratio of the Expenses (in $) of Salary of employees in 2005 to that in 2007?
Make the answer very short. 0.98. What is the ratio of the Expenses (in $) in Custom duties in 2005 to that in 2007?
Your answer should be very brief. 0.76. What is the ratio of the Expenses (in $) of Interest Payments in 2005 to that in 2007?
Give a very brief answer. 1.34. What is the ratio of the Expenses (in $) of Other expenses in 2005 to that in 2007?
Your answer should be compact. 0.89. What is the ratio of the Expenses (in $) in Salary of employees in 2005 to that in 2008?
Offer a terse response. 0.72. What is the ratio of the Expenses (in $) of Custom duties in 2005 to that in 2008?
Keep it short and to the point. 0.66. What is the ratio of the Expenses (in $) in Interest Payments in 2005 to that in 2008?
Ensure brevity in your answer.  0.67. What is the ratio of the Expenses (in $) of Other expenses in 2005 to that in 2008?
Ensure brevity in your answer.  0.73. What is the ratio of the Expenses (in $) of Salary of employees in 2006 to that in 2007?
Give a very brief answer. 0.96. What is the ratio of the Expenses (in $) in Custom duties in 2006 to that in 2007?
Your answer should be very brief. 0.86. What is the ratio of the Expenses (in $) in Interest Payments in 2006 to that in 2007?
Offer a very short reply. 1.98. What is the ratio of the Expenses (in $) of Other expenses in 2006 to that in 2007?
Provide a short and direct response. 0.97. What is the ratio of the Expenses (in $) of Salary of employees in 2006 to that in 2008?
Your answer should be compact. 0.71. What is the ratio of the Expenses (in $) of Custom duties in 2006 to that in 2008?
Provide a short and direct response. 0.74. What is the ratio of the Expenses (in $) in Interest Payments in 2006 to that in 2008?
Offer a very short reply. 0.98. What is the ratio of the Expenses (in $) in Other expenses in 2006 to that in 2008?
Make the answer very short. 0.8. What is the ratio of the Expenses (in $) in Salary of employees in 2007 to that in 2008?
Offer a very short reply. 0.74. What is the ratio of the Expenses (in $) in Custom duties in 2007 to that in 2008?
Your response must be concise. 0.86. What is the ratio of the Expenses (in $) of Interest Payments in 2007 to that in 2008?
Keep it short and to the point. 0.5. What is the ratio of the Expenses (in $) in Other expenses in 2007 to that in 2008?
Offer a terse response. 0.82. What is the difference between the highest and the second highest Expenses (in $) of Salary of employees?
Ensure brevity in your answer.  4.65e+1. What is the difference between the highest and the second highest Expenses (in $) in Custom duties?
Provide a short and direct response. 1.88e+1. What is the difference between the highest and the second highest Expenses (in $) in Interest Payments?
Provide a short and direct response. 1.92e+09. What is the difference between the highest and the second highest Expenses (in $) in Other expenses?
Your answer should be very brief. 7.39e+1. What is the difference between the highest and the lowest Expenses (in $) in Salary of employees?
Give a very brief answer. 7.40e+1. What is the difference between the highest and the lowest Expenses (in $) of Custom duties?
Make the answer very short. 5.66e+1. What is the difference between the highest and the lowest Expenses (in $) of Interest Payments?
Your answer should be very brief. 7.14e+09. What is the difference between the highest and the lowest Expenses (in $) in Other expenses?
Your answer should be very brief. 1.49e+11. 